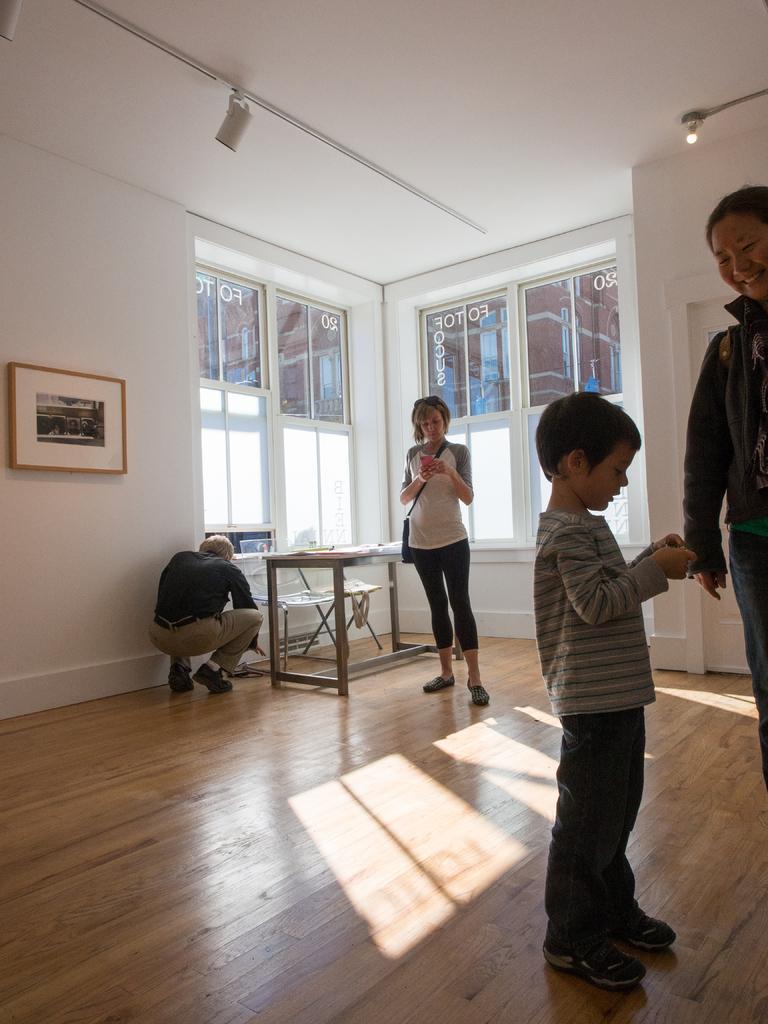In one or two sentences, can you explain what this image depicts? There are four people in a room. Of them a boy is standing with a woman in front. A girl is standing behind. A man is in squat position beside a table. 